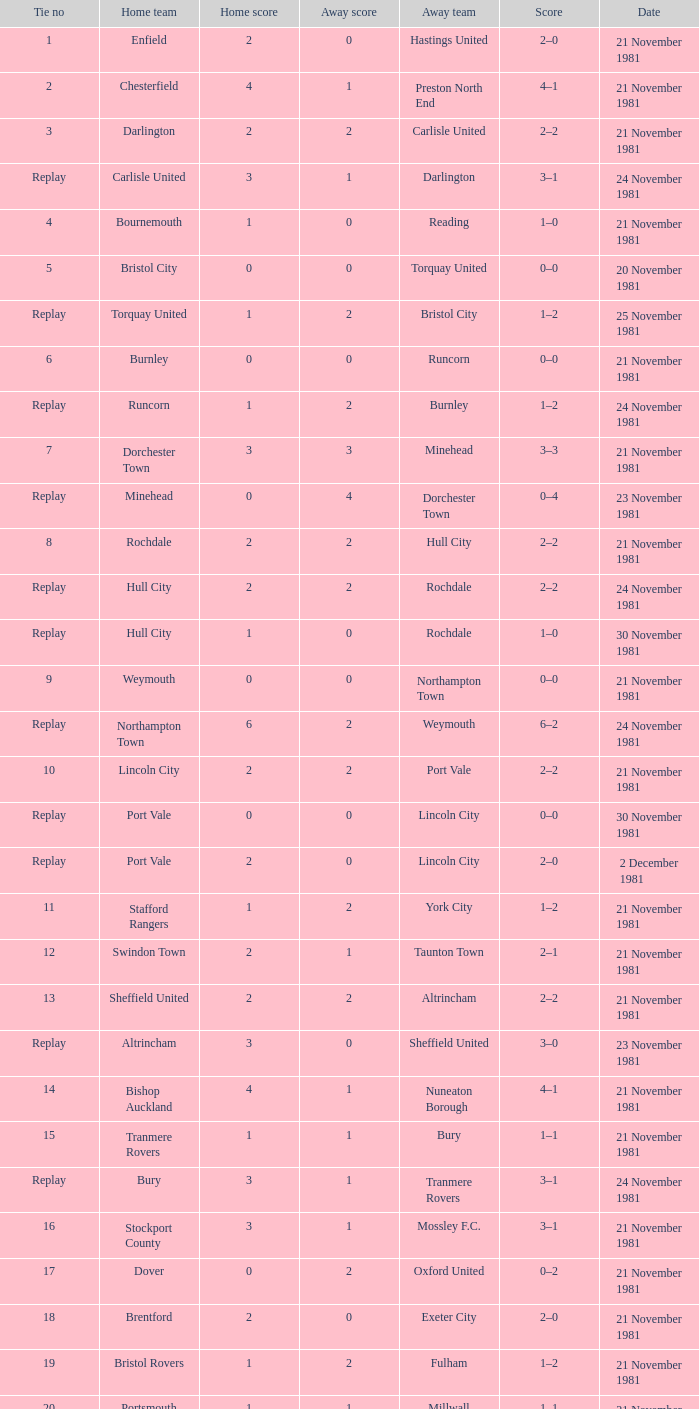What was the date of the fourth tie event? 21 November 1981. 